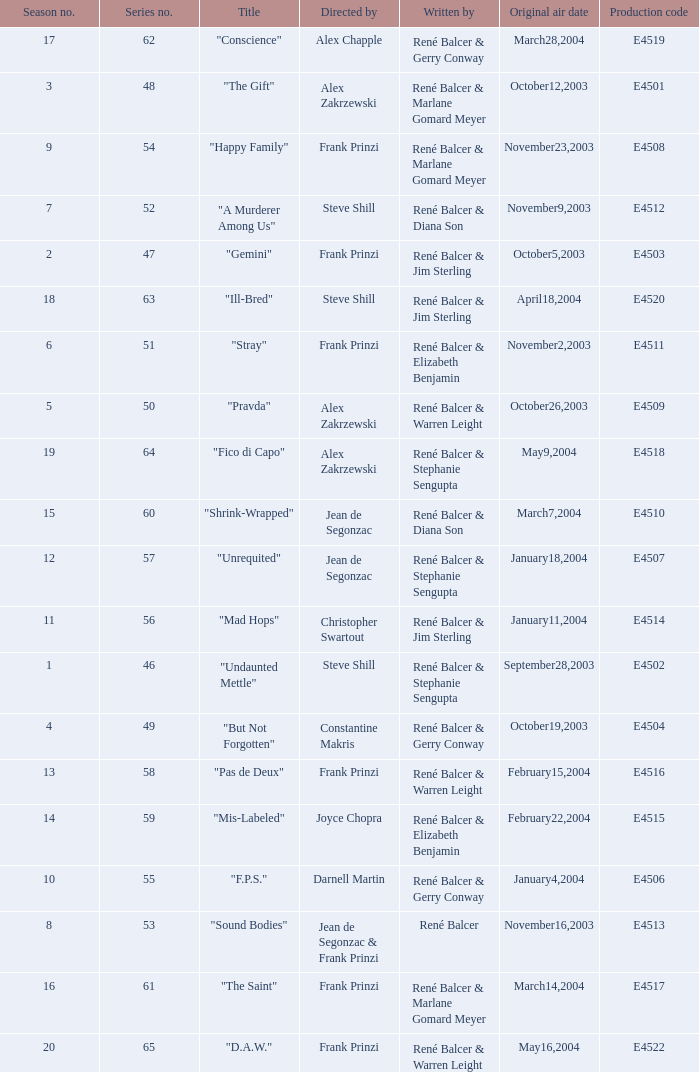Parse the full table. {'header': ['Season no.', 'Series no.', 'Title', 'Directed by', 'Written by', 'Original air date', 'Production code'], 'rows': [['17', '62', '"Conscience"', 'Alex Chapple', 'René Balcer & Gerry Conway', 'March28,2004', 'E4519'], ['3', '48', '"The Gift"', 'Alex Zakrzewski', 'René Balcer & Marlane Gomard Meyer', 'October12,2003', 'E4501'], ['9', '54', '"Happy Family"', 'Frank Prinzi', 'René Balcer & Marlane Gomard Meyer', 'November23,2003', 'E4508'], ['7', '52', '"A Murderer Among Us"', 'Steve Shill', 'René Balcer & Diana Son', 'November9,2003', 'E4512'], ['2', '47', '"Gemini"', 'Frank Prinzi', 'René Balcer & Jim Sterling', 'October5,2003', 'E4503'], ['18', '63', '"Ill-Bred"', 'Steve Shill', 'René Balcer & Jim Sterling', 'April18,2004', 'E4520'], ['6', '51', '"Stray"', 'Frank Prinzi', 'René Balcer & Elizabeth Benjamin', 'November2,2003', 'E4511'], ['5', '50', '"Pravda"', 'Alex Zakrzewski', 'René Balcer & Warren Leight', 'October26,2003', 'E4509'], ['19', '64', '"Fico di Capo"', 'Alex Zakrzewski', 'René Balcer & Stephanie Sengupta', 'May9,2004', 'E4518'], ['15', '60', '"Shrink-Wrapped"', 'Jean de Segonzac', 'René Balcer & Diana Son', 'March7,2004', 'E4510'], ['12', '57', '"Unrequited"', 'Jean de Segonzac', 'René Balcer & Stephanie Sengupta', 'January18,2004', 'E4507'], ['11', '56', '"Mad Hops"', 'Christopher Swartout', 'René Balcer & Jim Sterling', 'January11,2004', 'E4514'], ['1', '46', '"Undaunted Mettle"', 'Steve Shill', 'René Balcer & Stephanie Sengupta', 'September28,2003', 'E4502'], ['4', '49', '"But Not Forgotten"', 'Constantine Makris', 'René Balcer & Gerry Conway', 'October19,2003', 'E4504'], ['13', '58', '"Pas de Deux"', 'Frank Prinzi', 'René Balcer & Warren Leight', 'February15,2004', 'E4516'], ['14', '59', '"Mis-Labeled"', 'Joyce Chopra', 'René Balcer & Elizabeth Benjamin', 'February22,2004', 'E4515'], ['10', '55', '"F.P.S."', 'Darnell Martin', 'René Balcer & Gerry Conway', 'January4,2004', 'E4506'], ['8', '53', '"Sound Bodies"', 'Jean de Segonzac & Frank Prinzi', 'René Balcer', 'November16,2003', 'E4513'], ['16', '61', '"The Saint"', 'Frank Prinzi', 'René Balcer & Marlane Gomard Meyer', 'March14,2004', 'E4517'], ['20', '65', '"D.A.W."', 'Frank Prinzi', 'René Balcer & Warren Leight', 'May16,2004', 'E4522']]} Who wrote the episode with e4515 as the production code? René Balcer & Elizabeth Benjamin. 